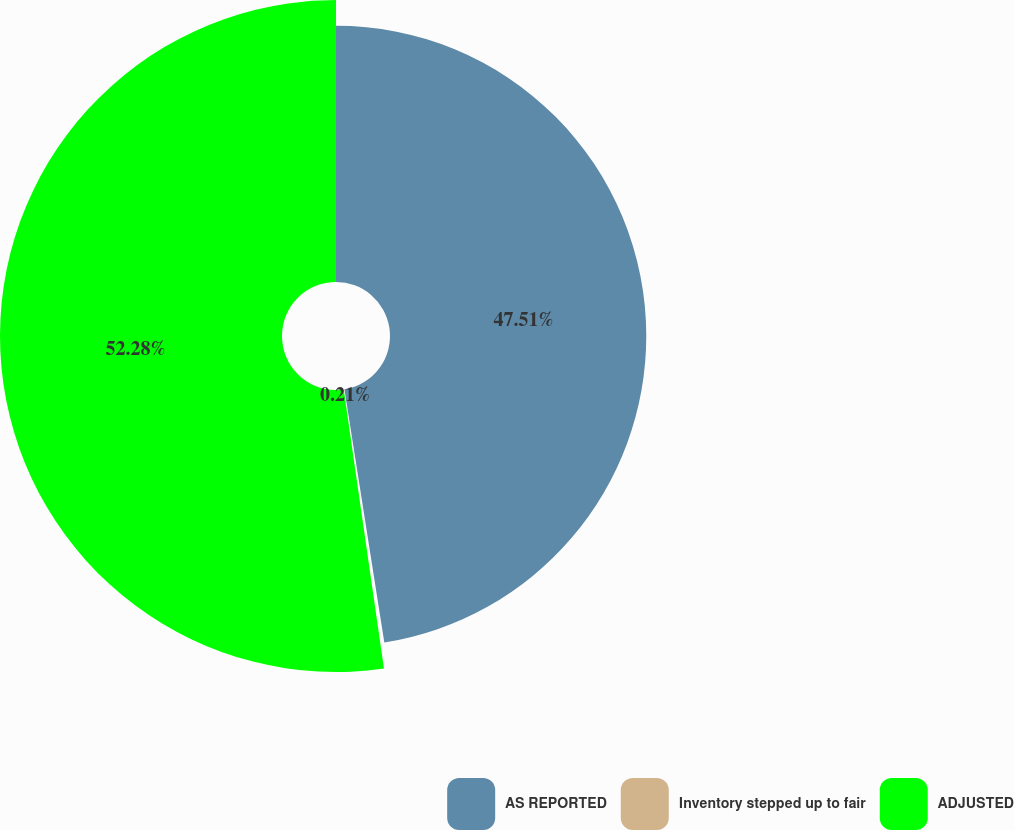Convert chart to OTSL. <chart><loc_0><loc_0><loc_500><loc_500><pie_chart><fcel>AS REPORTED<fcel>Inventory stepped up to fair<fcel>ADJUSTED<nl><fcel>47.51%<fcel>0.21%<fcel>52.28%<nl></chart> 